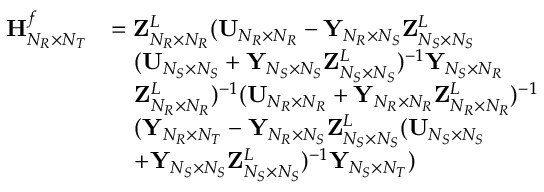<formula> <loc_0><loc_0><loc_500><loc_500>\begin{array} { r l } { { H } _ { N _ { R } \times N _ { T } } ^ { f } } & { = { Z } _ { N _ { R } \times N _ { R } } ^ { L } ( { U } _ { N _ { R } \times N _ { R } } - { Y } _ { N _ { R } \times N _ { S } } { Z } _ { N _ { S } \times N _ { S } } ^ { L } } \\ & { \quad ( { U } _ { N _ { S } \times N _ { S } } + { Y } _ { N _ { S } \times N _ { S } } { Z } _ { N _ { S } \times N _ { S } } ^ { L } ) ^ { - 1 } { Y } _ { N _ { S } \times N _ { R } } } \\ & { \quad Z _ { N _ { R } \times N _ { R } } ^ { L } ) ^ { - 1 } ( { U } _ { N _ { R } \times N _ { R } } + { Y } _ { N _ { R } \times N _ { R } } { Z } _ { N _ { R } \times N _ { R } } ^ { L } ) ^ { - 1 } } \\ & { \quad ( { Y } _ { N _ { R } \times N _ { T } } - { Y } _ { N _ { R } \times N _ { S } } { Z } _ { N _ { S } \times N _ { S } } ^ { L } ( { U } _ { N _ { S } \times N _ { S } } } \\ & { \quad + { Y } _ { N _ { S } \times N _ { S } } { Z } _ { N _ { S } \times N _ { S } } ^ { L } ) ^ { - 1 } { Y } _ { N _ { S } \times N _ { T } } ) } \end{array}</formula> 